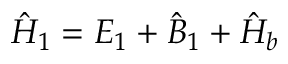<formula> <loc_0><loc_0><loc_500><loc_500>\hat { H } _ { 1 } = E _ { 1 } + \hat { B } _ { 1 } + \hat { H } _ { b }</formula> 